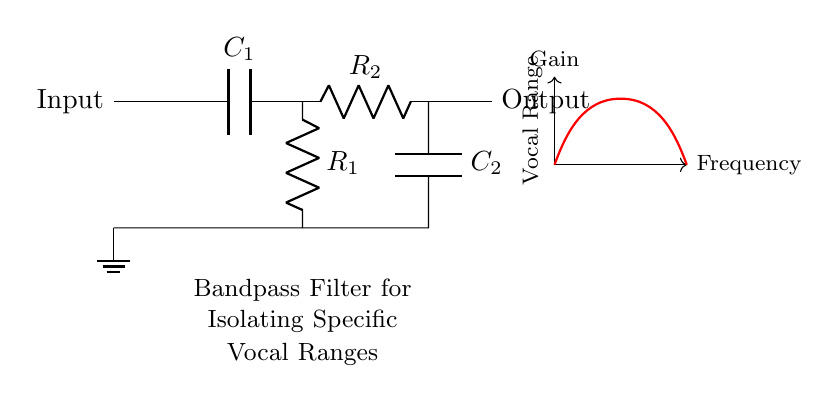What are the components in this circuit? The components in the circuit include two capacitors (C₁ and C₂) and two resistors (R₁ and R₂). They are arranged in a specific configuration to create a bandpass filter.
Answer: Capacitors and resistors What is the function of the high-pass section? The high-pass section, consisting of capacitor C₁ and resistor R₁, allows frequencies above a certain cutoff frequency to pass through while attenuating lower frequencies.
Answer: To allow high frequencies What is the purpose of the low-pass section? The low-pass section, made up of resistor R₂ and capacitor C₂, permits frequencies below a certain cutoff frequency to pass through while attenuating higher frequencies.
Answer: To allow low frequencies What is the total number of components in this circuit? The circuit contains four components: two resistors and two capacitors.
Answer: Four Which component determines the leading frequency cutoff? Capacitor C₁ in the high-pass section determines the leading (high-frequency) cutoff, which is crucial for isolating the desired vocal ranges.
Answer: Capacitor C₁ What type of filter is represented in the circuit? The circuit is a bandpass filter, as it combines both high-pass and low-pass functionalities to isolate a specific range of frequencies for voice analysis.
Answer: Bandpass filter 